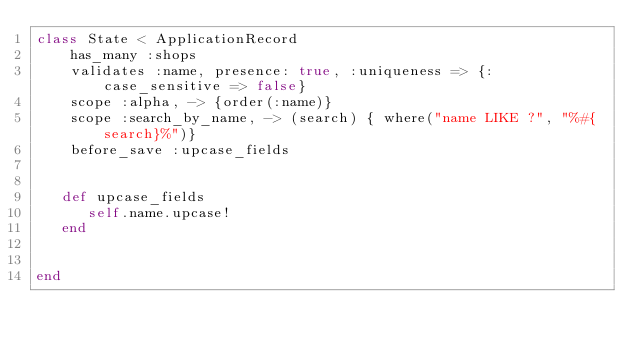Convert code to text. <code><loc_0><loc_0><loc_500><loc_500><_Ruby_>class State < ApplicationRecord
    has_many :shops
    validates :name, presence: true, :uniqueness => {:case_sensitive => false}
    scope :alpha, -> {order(:name)}
    scope :search_by_name, -> (search) { where("name LIKE ?", "%#{search}%")}
    before_save :upcase_fields
    

   def upcase_fields
      self.name.upcase!
   end


end
</code> 